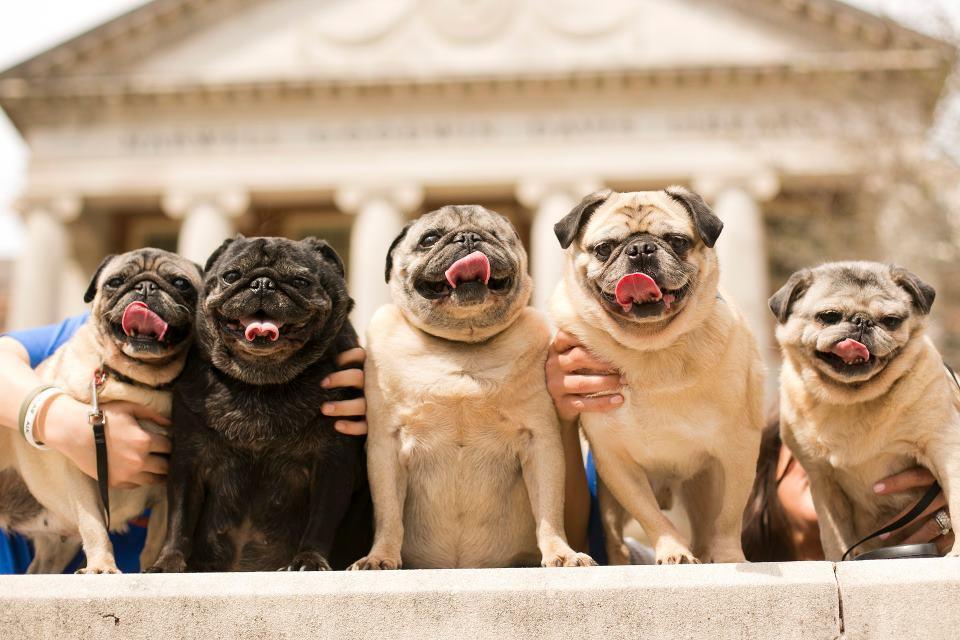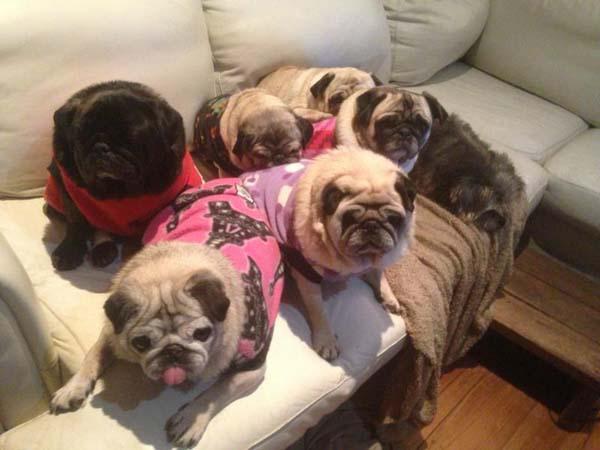The first image is the image on the left, the second image is the image on the right. Given the left and right images, does the statement "There are exactly five dogs in one of the images." hold true? Answer yes or no. Yes. 